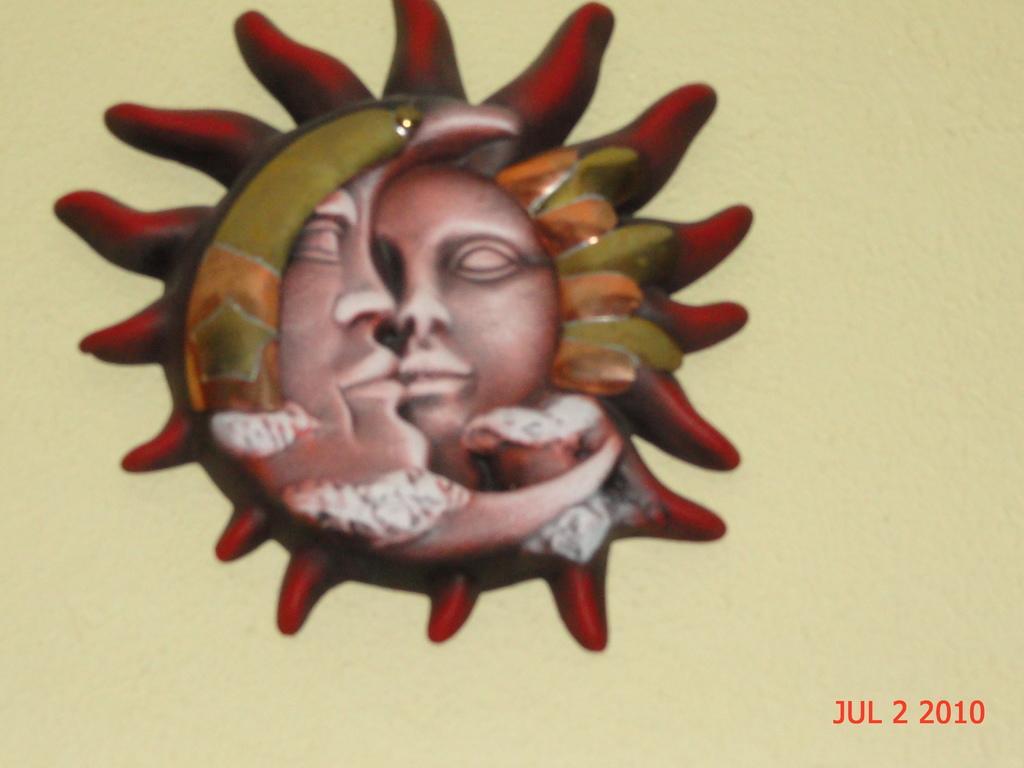Please provide a concise description of this image. In the center of the image, we can see a decor on the wall and at the bottom, there is some text. 